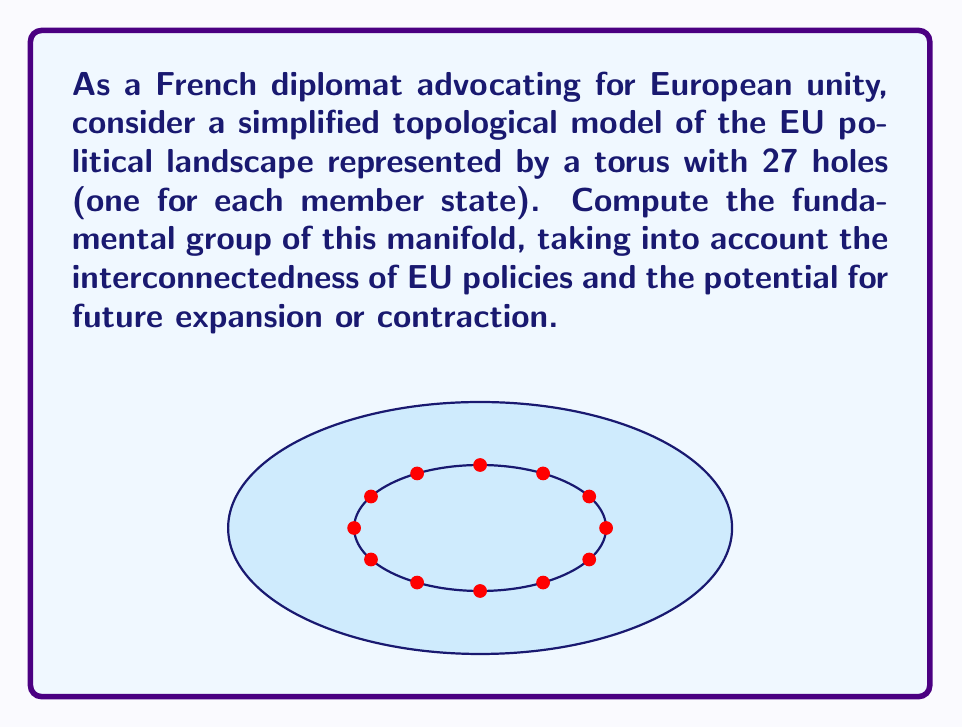What is the answer to this math problem? To compute the fundamental group of this manifold, we'll follow these steps:

1) First, recall that the fundamental group of a torus $T^2$ is:

   $\pi_1(T^2) \cong \mathbb{Z} \times \mathbb{Z}$

2) For each hole we add to the torus, we essentially add a free generator to the fundamental group. This is because each hole creates a new non-contractible loop that can't be reduced to the existing generators.

3) In our case, we have a torus with 27 additional holes. So, we need to add 27 free generators to the fundamental group of the torus.

4) The resulting fundamental group will be the free product of the torus group with 27 copies of $\mathbb{Z}$:

   $\pi_1(M) \cong (\mathbb{Z} \times \mathbb{Z}) * \underbrace{\mathbb{Z} * \mathbb{Z} * ... * \mathbb{Z}}_{27 \text{ times}}$

5) We can simplify this notation by using the free group on 29 generators:

   $\pi_1(M) \cong F_{29}$

This result reflects the complex interconnectedness of EU policies (represented by the torus) and the individual influence of each member state (represented by the additional holes/generators).
Answer: $F_{29}$ 